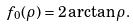<formula> <loc_0><loc_0><loc_500><loc_500>f _ { 0 } ( \rho ) = 2 \arctan \rho .</formula> 